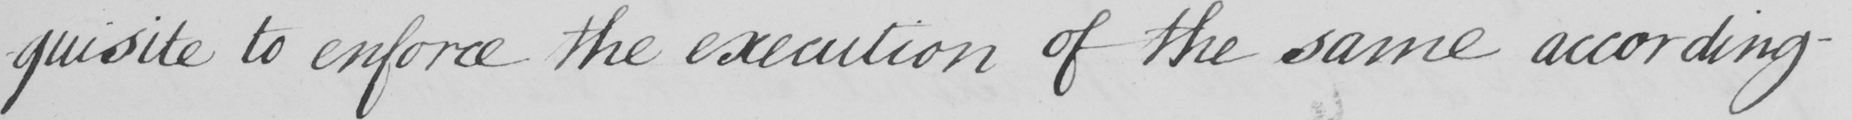Please transcribe the handwritten text in this image. -quisite to enforce the execution of the same according- 